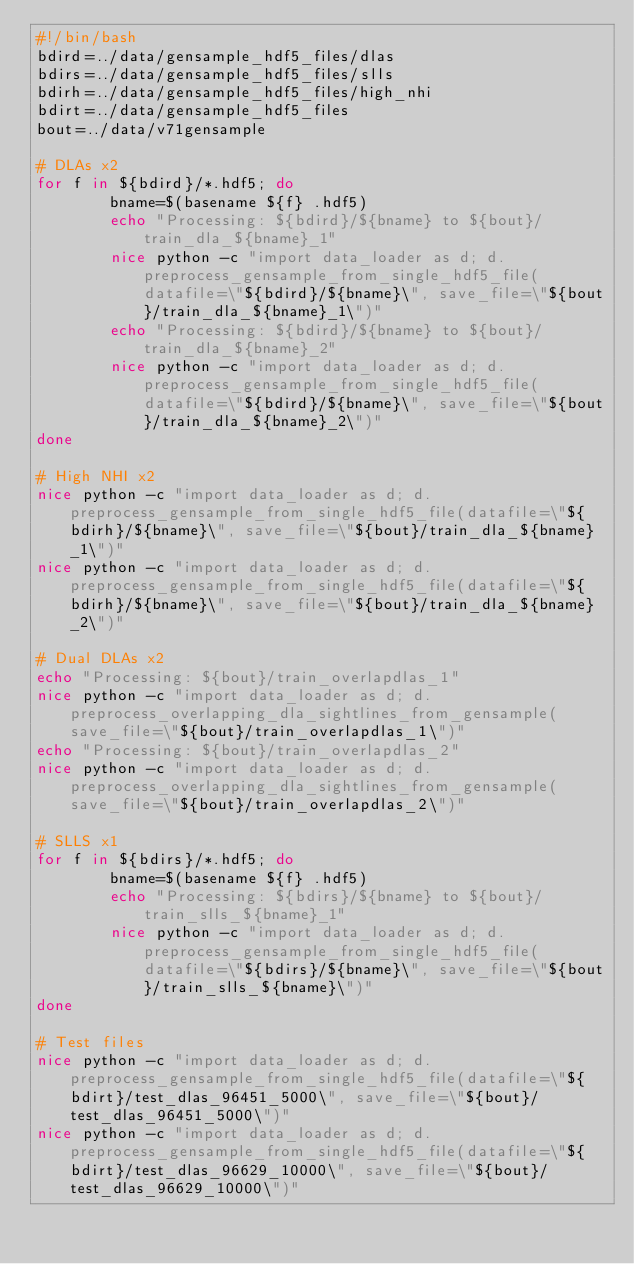Convert code to text. <code><loc_0><loc_0><loc_500><loc_500><_Bash_>#!/bin/bash
bdird=../data/gensample_hdf5_files/dlas
bdirs=../data/gensample_hdf5_files/slls
bdirh=../data/gensample_hdf5_files/high_nhi
bdirt=../data/gensample_hdf5_files
bout=../data/v71gensample

# DLAs x2
for f in ${bdird}/*.hdf5; do
        bname=$(basename ${f} .hdf5)
        echo "Processing: ${bdird}/${bname} to ${bout}/train_dla_${bname}_1"
        nice python -c "import data_loader as d; d.preprocess_gensample_from_single_hdf5_file(datafile=\"${bdird}/${bname}\", save_file=\"${bout}/train_dla_${bname}_1\")"
        echo "Processing: ${bdird}/${bname} to ${bout}/train_dla_${bname}_2"
        nice python -c "import data_loader as d; d.preprocess_gensample_from_single_hdf5_file(datafile=\"${bdird}/${bname}\", save_file=\"${bout}/train_dla_${bname}_2\")"
done

# High NHI x2
nice python -c "import data_loader as d; d.preprocess_gensample_from_single_hdf5_file(datafile=\"${bdirh}/${bname}\", save_file=\"${bout}/train_dla_${bname}_1\")"
nice python -c "import data_loader as d; d.preprocess_gensample_from_single_hdf5_file(datafile=\"${bdirh}/${bname}\", save_file=\"${bout}/train_dla_${bname}_2\")"

# Dual DLAs x2
echo "Processing: ${bout}/train_overlapdlas_1"
nice python -c "import data_loader as d; d.preprocess_overlapping_dla_sightlines_from_gensample(save_file=\"${bout}/train_overlapdlas_1\")"
echo "Processing: ${bout}/train_overlapdlas_2"
nice python -c "import data_loader as d; d.preprocess_overlapping_dla_sightlines_from_gensample(save_file=\"${bout}/train_overlapdlas_2\")"

# SLLS x1
for f in ${bdirs}/*.hdf5; do
        bname=$(basename ${f} .hdf5)
        echo "Processing: ${bdirs}/${bname} to ${bout}/train_slls_${bname}_1"
        nice python -c "import data_loader as d; d.preprocess_gensample_from_single_hdf5_file(datafile=\"${bdirs}/${bname}\", save_file=\"${bout}/train_slls_${bname}\")"
done

# Test files
nice python -c "import data_loader as d; d.preprocess_gensample_from_single_hdf5_file(datafile=\"${bdirt}/test_dlas_96451_5000\", save_file=\"${bout}/test_dlas_96451_5000\")"
nice python -c "import data_loader as d; d.preprocess_gensample_from_single_hdf5_file(datafile=\"${bdirt}/test_dlas_96629_10000\", save_file=\"${bout}/test_dlas_96629_10000\")"</code> 